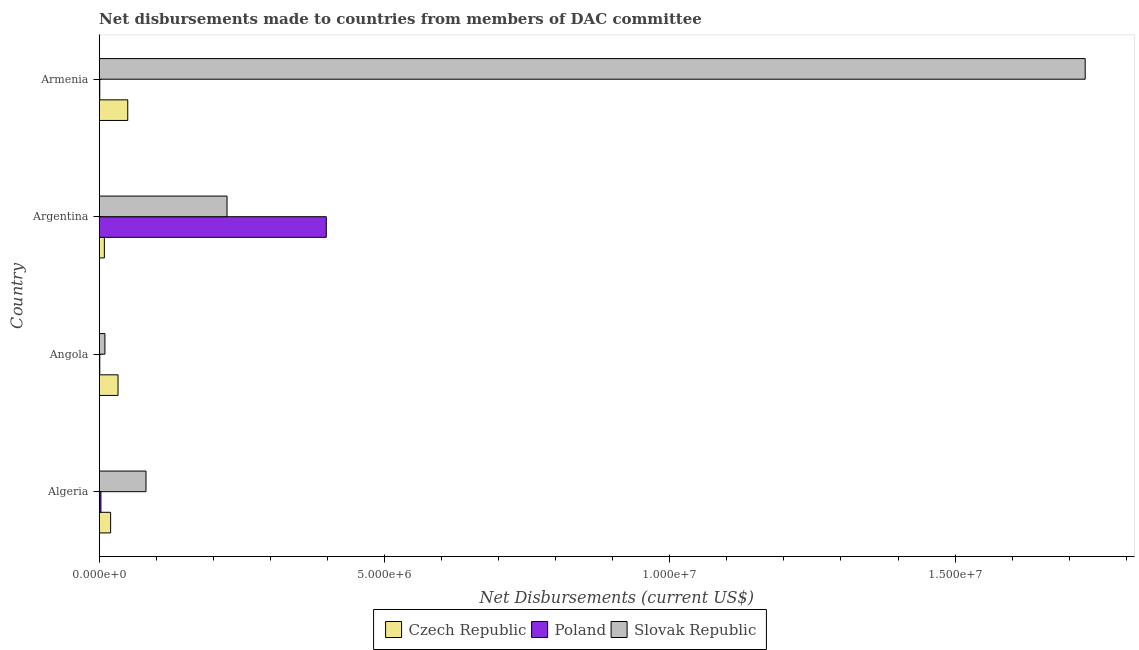How many groups of bars are there?
Offer a very short reply. 4. How many bars are there on the 3rd tick from the top?
Give a very brief answer. 3. How many bars are there on the 4th tick from the bottom?
Give a very brief answer. 3. What is the label of the 3rd group of bars from the top?
Provide a succinct answer. Angola. What is the net disbursements made by czech republic in Algeria?
Give a very brief answer. 2.00e+05. Across all countries, what is the maximum net disbursements made by poland?
Your answer should be compact. 3.98e+06. Across all countries, what is the minimum net disbursements made by czech republic?
Keep it short and to the point. 9.00e+04. In which country was the net disbursements made by czech republic maximum?
Give a very brief answer. Armenia. What is the total net disbursements made by slovak republic in the graph?
Ensure brevity in your answer.  2.04e+07. What is the difference between the net disbursements made by poland in Algeria and that in Armenia?
Ensure brevity in your answer.  2.00e+04. What is the difference between the net disbursements made by poland in Angola and the net disbursements made by czech republic in Argentina?
Provide a short and direct response. -8.00e+04. What is the difference between the net disbursements made by czech republic and net disbursements made by slovak republic in Algeria?
Your answer should be very brief. -6.20e+05. What is the ratio of the net disbursements made by slovak republic in Argentina to that in Armenia?
Offer a terse response. 0.13. Is the net disbursements made by czech republic in Argentina less than that in Armenia?
Your answer should be very brief. Yes. What is the difference between the highest and the second highest net disbursements made by slovak republic?
Provide a short and direct response. 1.50e+07. What is the difference between the highest and the lowest net disbursements made by poland?
Your answer should be very brief. 3.97e+06. Is the sum of the net disbursements made by poland in Angola and Argentina greater than the maximum net disbursements made by czech republic across all countries?
Your answer should be compact. Yes. What does the 1st bar from the top in Algeria represents?
Offer a very short reply. Slovak Republic. What does the 3rd bar from the bottom in Argentina represents?
Offer a very short reply. Slovak Republic. How many bars are there?
Give a very brief answer. 12. What is the difference between two consecutive major ticks on the X-axis?
Your answer should be compact. 5.00e+06. Are the values on the major ticks of X-axis written in scientific E-notation?
Your response must be concise. Yes. Does the graph contain grids?
Provide a succinct answer. No. Where does the legend appear in the graph?
Give a very brief answer. Bottom center. How many legend labels are there?
Provide a short and direct response. 3. How are the legend labels stacked?
Make the answer very short. Horizontal. What is the title of the graph?
Your answer should be very brief. Net disbursements made to countries from members of DAC committee. What is the label or title of the X-axis?
Your answer should be compact. Net Disbursements (current US$). What is the label or title of the Y-axis?
Make the answer very short. Country. What is the Net Disbursements (current US$) in Czech Republic in Algeria?
Your response must be concise. 2.00e+05. What is the Net Disbursements (current US$) of Poland in Algeria?
Provide a short and direct response. 3.00e+04. What is the Net Disbursements (current US$) in Slovak Republic in Algeria?
Provide a short and direct response. 8.20e+05. What is the Net Disbursements (current US$) in Poland in Angola?
Offer a very short reply. 10000. What is the Net Disbursements (current US$) of Czech Republic in Argentina?
Your answer should be compact. 9.00e+04. What is the Net Disbursements (current US$) in Poland in Argentina?
Provide a succinct answer. 3.98e+06. What is the Net Disbursements (current US$) in Slovak Republic in Argentina?
Ensure brevity in your answer.  2.24e+06. What is the Net Disbursements (current US$) in Czech Republic in Armenia?
Your answer should be compact. 5.00e+05. What is the Net Disbursements (current US$) in Slovak Republic in Armenia?
Offer a very short reply. 1.73e+07. Across all countries, what is the maximum Net Disbursements (current US$) in Czech Republic?
Make the answer very short. 5.00e+05. Across all countries, what is the maximum Net Disbursements (current US$) of Poland?
Give a very brief answer. 3.98e+06. Across all countries, what is the maximum Net Disbursements (current US$) of Slovak Republic?
Offer a terse response. 1.73e+07. Across all countries, what is the minimum Net Disbursements (current US$) of Poland?
Give a very brief answer. 10000. What is the total Net Disbursements (current US$) of Czech Republic in the graph?
Give a very brief answer. 1.12e+06. What is the total Net Disbursements (current US$) in Poland in the graph?
Ensure brevity in your answer.  4.03e+06. What is the total Net Disbursements (current US$) in Slovak Republic in the graph?
Provide a short and direct response. 2.04e+07. What is the difference between the Net Disbursements (current US$) of Czech Republic in Algeria and that in Angola?
Your answer should be very brief. -1.30e+05. What is the difference between the Net Disbursements (current US$) in Slovak Republic in Algeria and that in Angola?
Ensure brevity in your answer.  7.20e+05. What is the difference between the Net Disbursements (current US$) of Poland in Algeria and that in Argentina?
Keep it short and to the point. -3.95e+06. What is the difference between the Net Disbursements (current US$) of Slovak Republic in Algeria and that in Argentina?
Ensure brevity in your answer.  -1.42e+06. What is the difference between the Net Disbursements (current US$) in Slovak Republic in Algeria and that in Armenia?
Keep it short and to the point. -1.65e+07. What is the difference between the Net Disbursements (current US$) of Poland in Angola and that in Argentina?
Provide a short and direct response. -3.97e+06. What is the difference between the Net Disbursements (current US$) of Slovak Republic in Angola and that in Argentina?
Ensure brevity in your answer.  -2.14e+06. What is the difference between the Net Disbursements (current US$) in Czech Republic in Angola and that in Armenia?
Keep it short and to the point. -1.70e+05. What is the difference between the Net Disbursements (current US$) of Poland in Angola and that in Armenia?
Keep it short and to the point. 0. What is the difference between the Net Disbursements (current US$) in Slovak Republic in Angola and that in Armenia?
Ensure brevity in your answer.  -1.72e+07. What is the difference between the Net Disbursements (current US$) of Czech Republic in Argentina and that in Armenia?
Provide a succinct answer. -4.10e+05. What is the difference between the Net Disbursements (current US$) of Poland in Argentina and that in Armenia?
Your answer should be very brief. 3.97e+06. What is the difference between the Net Disbursements (current US$) in Slovak Republic in Argentina and that in Armenia?
Your response must be concise. -1.50e+07. What is the difference between the Net Disbursements (current US$) of Poland in Algeria and the Net Disbursements (current US$) of Slovak Republic in Angola?
Keep it short and to the point. -7.00e+04. What is the difference between the Net Disbursements (current US$) of Czech Republic in Algeria and the Net Disbursements (current US$) of Poland in Argentina?
Your response must be concise. -3.78e+06. What is the difference between the Net Disbursements (current US$) in Czech Republic in Algeria and the Net Disbursements (current US$) in Slovak Republic in Argentina?
Provide a succinct answer. -2.04e+06. What is the difference between the Net Disbursements (current US$) of Poland in Algeria and the Net Disbursements (current US$) of Slovak Republic in Argentina?
Give a very brief answer. -2.21e+06. What is the difference between the Net Disbursements (current US$) of Czech Republic in Algeria and the Net Disbursements (current US$) of Poland in Armenia?
Your response must be concise. 1.90e+05. What is the difference between the Net Disbursements (current US$) of Czech Republic in Algeria and the Net Disbursements (current US$) of Slovak Republic in Armenia?
Provide a short and direct response. -1.71e+07. What is the difference between the Net Disbursements (current US$) in Poland in Algeria and the Net Disbursements (current US$) in Slovak Republic in Armenia?
Keep it short and to the point. -1.72e+07. What is the difference between the Net Disbursements (current US$) in Czech Republic in Angola and the Net Disbursements (current US$) in Poland in Argentina?
Offer a terse response. -3.65e+06. What is the difference between the Net Disbursements (current US$) in Czech Republic in Angola and the Net Disbursements (current US$) in Slovak Republic in Argentina?
Your answer should be compact. -1.91e+06. What is the difference between the Net Disbursements (current US$) of Poland in Angola and the Net Disbursements (current US$) of Slovak Republic in Argentina?
Give a very brief answer. -2.23e+06. What is the difference between the Net Disbursements (current US$) of Czech Republic in Angola and the Net Disbursements (current US$) of Slovak Republic in Armenia?
Provide a short and direct response. -1.70e+07. What is the difference between the Net Disbursements (current US$) of Poland in Angola and the Net Disbursements (current US$) of Slovak Republic in Armenia?
Keep it short and to the point. -1.73e+07. What is the difference between the Net Disbursements (current US$) in Czech Republic in Argentina and the Net Disbursements (current US$) in Poland in Armenia?
Keep it short and to the point. 8.00e+04. What is the difference between the Net Disbursements (current US$) of Czech Republic in Argentina and the Net Disbursements (current US$) of Slovak Republic in Armenia?
Your response must be concise. -1.72e+07. What is the difference between the Net Disbursements (current US$) of Poland in Argentina and the Net Disbursements (current US$) of Slovak Republic in Armenia?
Keep it short and to the point. -1.33e+07. What is the average Net Disbursements (current US$) in Poland per country?
Your answer should be compact. 1.01e+06. What is the average Net Disbursements (current US$) in Slovak Republic per country?
Offer a very short reply. 5.11e+06. What is the difference between the Net Disbursements (current US$) in Czech Republic and Net Disbursements (current US$) in Poland in Algeria?
Your response must be concise. 1.70e+05. What is the difference between the Net Disbursements (current US$) in Czech Republic and Net Disbursements (current US$) in Slovak Republic in Algeria?
Your response must be concise. -6.20e+05. What is the difference between the Net Disbursements (current US$) of Poland and Net Disbursements (current US$) of Slovak Republic in Algeria?
Make the answer very short. -7.90e+05. What is the difference between the Net Disbursements (current US$) of Czech Republic and Net Disbursements (current US$) of Poland in Angola?
Ensure brevity in your answer.  3.20e+05. What is the difference between the Net Disbursements (current US$) of Czech Republic and Net Disbursements (current US$) of Slovak Republic in Angola?
Your answer should be very brief. 2.30e+05. What is the difference between the Net Disbursements (current US$) in Poland and Net Disbursements (current US$) in Slovak Republic in Angola?
Your response must be concise. -9.00e+04. What is the difference between the Net Disbursements (current US$) in Czech Republic and Net Disbursements (current US$) in Poland in Argentina?
Ensure brevity in your answer.  -3.89e+06. What is the difference between the Net Disbursements (current US$) in Czech Republic and Net Disbursements (current US$) in Slovak Republic in Argentina?
Provide a short and direct response. -2.15e+06. What is the difference between the Net Disbursements (current US$) in Poland and Net Disbursements (current US$) in Slovak Republic in Argentina?
Make the answer very short. 1.74e+06. What is the difference between the Net Disbursements (current US$) in Czech Republic and Net Disbursements (current US$) in Slovak Republic in Armenia?
Your response must be concise. -1.68e+07. What is the difference between the Net Disbursements (current US$) in Poland and Net Disbursements (current US$) in Slovak Republic in Armenia?
Your answer should be compact. -1.73e+07. What is the ratio of the Net Disbursements (current US$) in Czech Republic in Algeria to that in Angola?
Give a very brief answer. 0.61. What is the ratio of the Net Disbursements (current US$) of Czech Republic in Algeria to that in Argentina?
Ensure brevity in your answer.  2.22. What is the ratio of the Net Disbursements (current US$) of Poland in Algeria to that in Argentina?
Your response must be concise. 0.01. What is the ratio of the Net Disbursements (current US$) of Slovak Republic in Algeria to that in Argentina?
Make the answer very short. 0.37. What is the ratio of the Net Disbursements (current US$) in Czech Republic in Algeria to that in Armenia?
Your response must be concise. 0.4. What is the ratio of the Net Disbursements (current US$) of Slovak Republic in Algeria to that in Armenia?
Give a very brief answer. 0.05. What is the ratio of the Net Disbursements (current US$) in Czech Republic in Angola to that in Argentina?
Keep it short and to the point. 3.67. What is the ratio of the Net Disbursements (current US$) of Poland in Angola to that in Argentina?
Provide a short and direct response. 0. What is the ratio of the Net Disbursements (current US$) in Slovak Republic in Angola to that in Argentina?
Your answer should be very brief. 0.04. What is the ratio of the Net Disbursements (current US$) in Czech Republic in Angola to that in Armenia?
Your answer should be compact. 0.66. What is the ratio of the Net Disbursements (current US$) in Slovak Republic in Angola to that in Armenia?
Offer a terse response. 0.01. What is the ratio of the Net Disbursements (current US$) of Czech Republic in Argentina to that in Armenia?
Make the answer very short. 0.18. What is the ratio of the Net Disbursements (current US$) of Poland in Argentina to that in Armenia?
Ensure brevity in your answer.  398. What is the ratio of the Net Disbursements (current US$) in Slovak Republic in Argentina to that in Armenia?
Your response must be concise. 0.13. What is the difference between the highest and the second highest Net Disbursements (current US$) in Poland?
Ensure brevity in your answer.  3.95e+06. What is the difference between the highest and the second highest Net Disbursements (current US$) in Slovak Republic?
Your answer should be compact. 1.50e+07. What is the difference between the highest and the lowest Net Disbursements (current US$) of Poland?
Offer a terse response. 3.97e+06. What is the difference between the highest and the lowest Net Disbursements (current US$) in Slovak Republic?
Ensure brevity in your answer.  1.72e+07. 